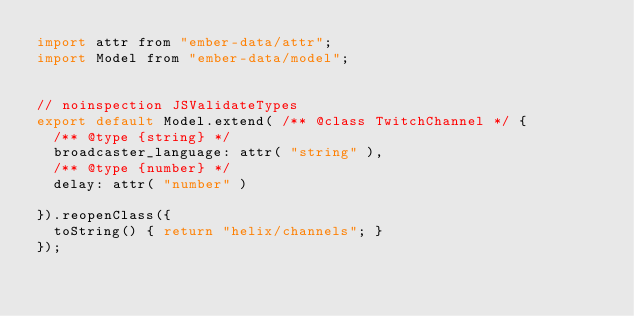<code> <loc_0><loc_0><loc_500><loc_500><_JavaScript_>import attr from "ember-data/attr";
import Model from "ember-data/model";


// noinspection JSValidateTypes
export default Model.extend( /** @class TwitchChannel */ {
	/** @type {string} */
	broadcaster_language: attr( "string" ),
	/** @type {number} */
	delay: attr( "number" )

}).reopenClass({
	toString() { return "helix/channels"; }
});
</code> 